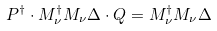<formula> <loc_0><loc_0><loc_500><loc_500>P ^ { \dagger } \cdot M _ { \nu } ^ { \dagger } M _ { \nu } \Delta \cdot Q = M _ { \nu } ^ { \dagger } M _ { \nu } \Delta</formula> 